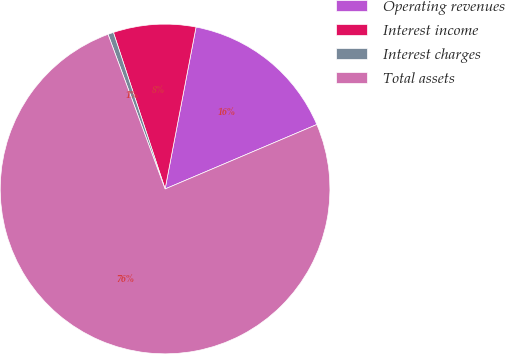Convert chart. <chart><loc_0><loc_0><loc_500><loc_500><pie_chart><fcel>Operating revenues<fcel>Interest income<fcel>Interest charges<fcel>Total assets<nl><fcel>15.6%<fcel>8.08%<fcel>0.55%<fcel>75.77%<nl></chart> 